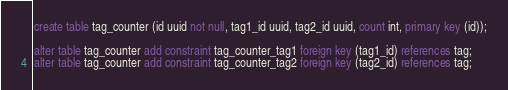Convert code to text. <code><loc_0><loc_0><loc_500><loc_500><_SQL_>create table tag_counter (id uuid not null, tag1_id uuid, tag2_id uuid, count int, primary key (id));

alter table tag_counter add constraint tag_counter_tag1 foreign key (tag1_id) references tag;
alter table tag_counter add constraint tag_counter_tag2 foreign key (tag2_id) references tag;
</code> 